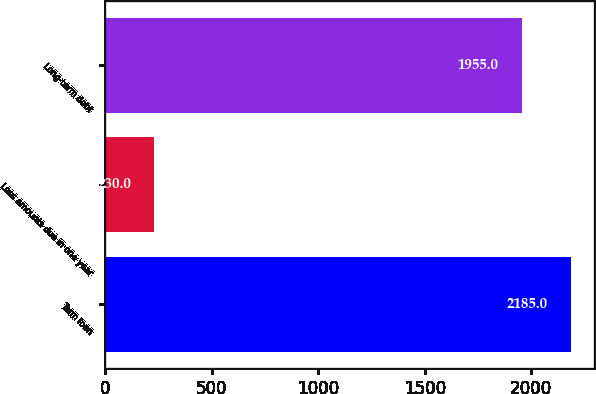Convert chart to OTSL. <chart><loc_0><loc_0><loc_500><loc_500><bar_chart><fcel>Term loan<fcel>Less amounts due in one year<fcel>Long-term debt<nl><fcel>2185<fcel>230<fcel>1955<nl></chart> 